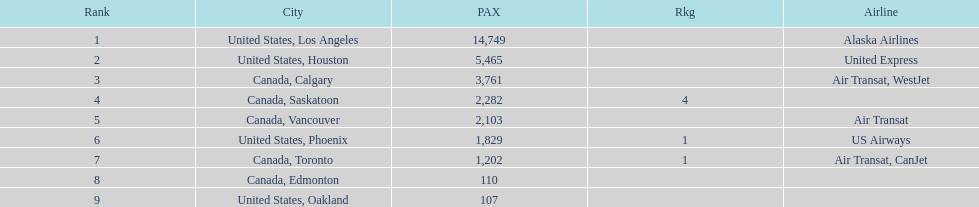How many airlines have a steady ranking? 4. 